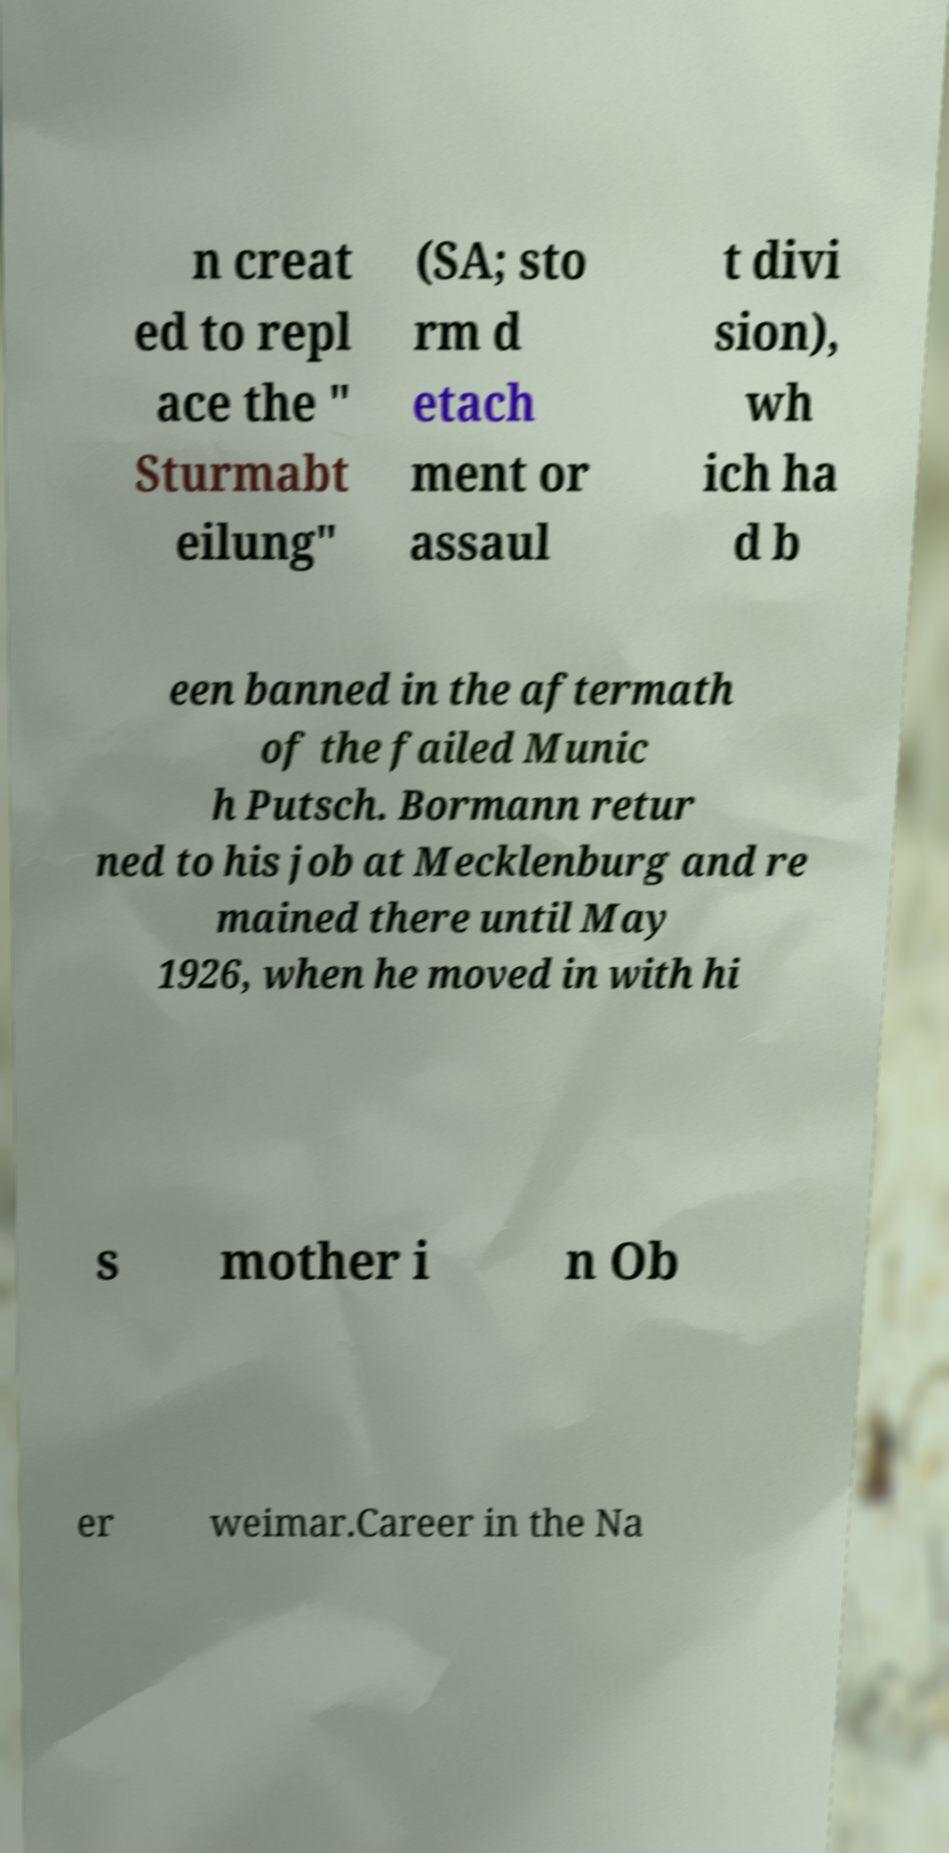Can you accurately transcribe the text from the provided image for me? n creat ed to repl ace the " Sturmabt eilung" (SA; sto rm d etach ment or assaul t divi sion), wh ich ha d b een banned in the aftermath of the failed Munic h Putsch. Bormann retur ned to his job at Mecklenburg and re mained there until May 1926, when he moved in with hi s mother i n Ob er weimar.Career in the Na 